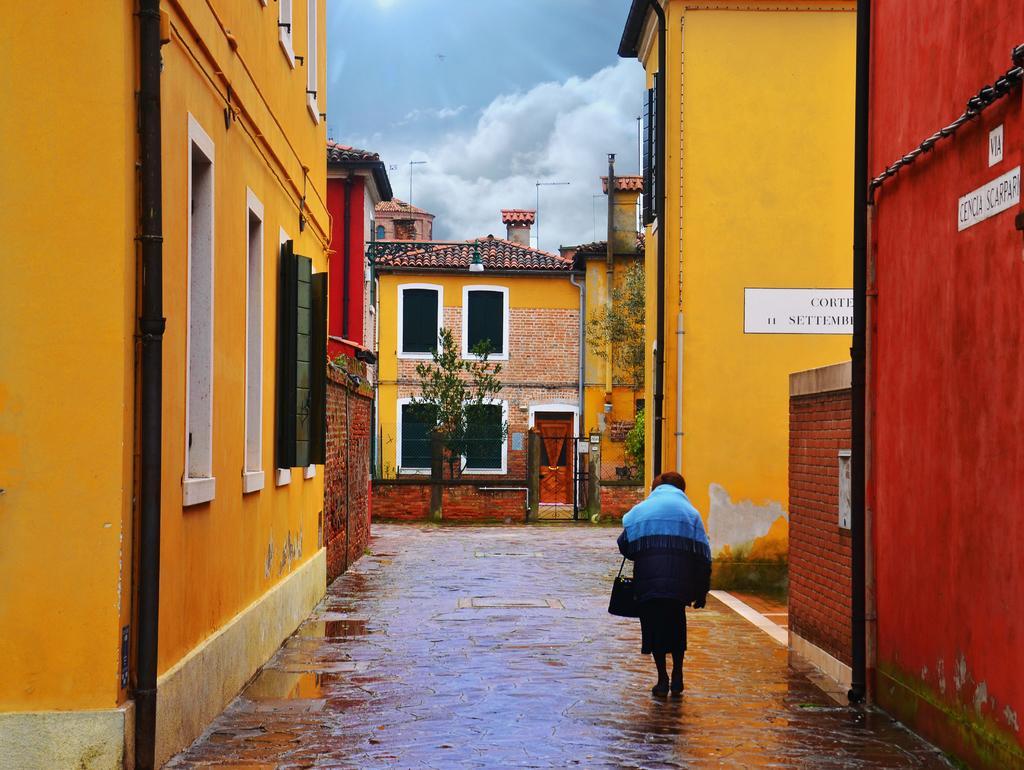How would you summarize this image in a sentence or two? In the center of the image we can see a person walking on the road. Image also consists of many buildings and also trees. We can also see the sky with the clouds. 